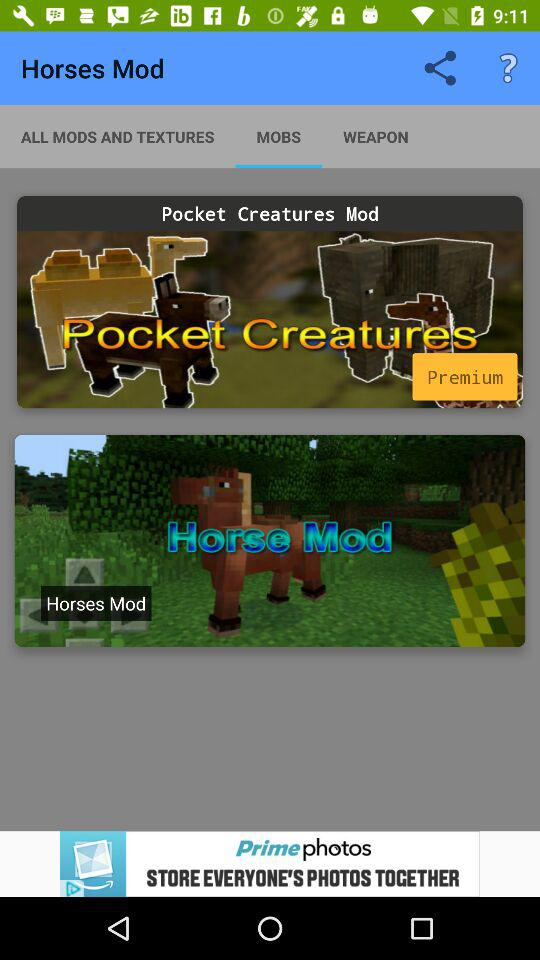Which option is selected in "Horses Mod"? The selected option is "MOBS". 